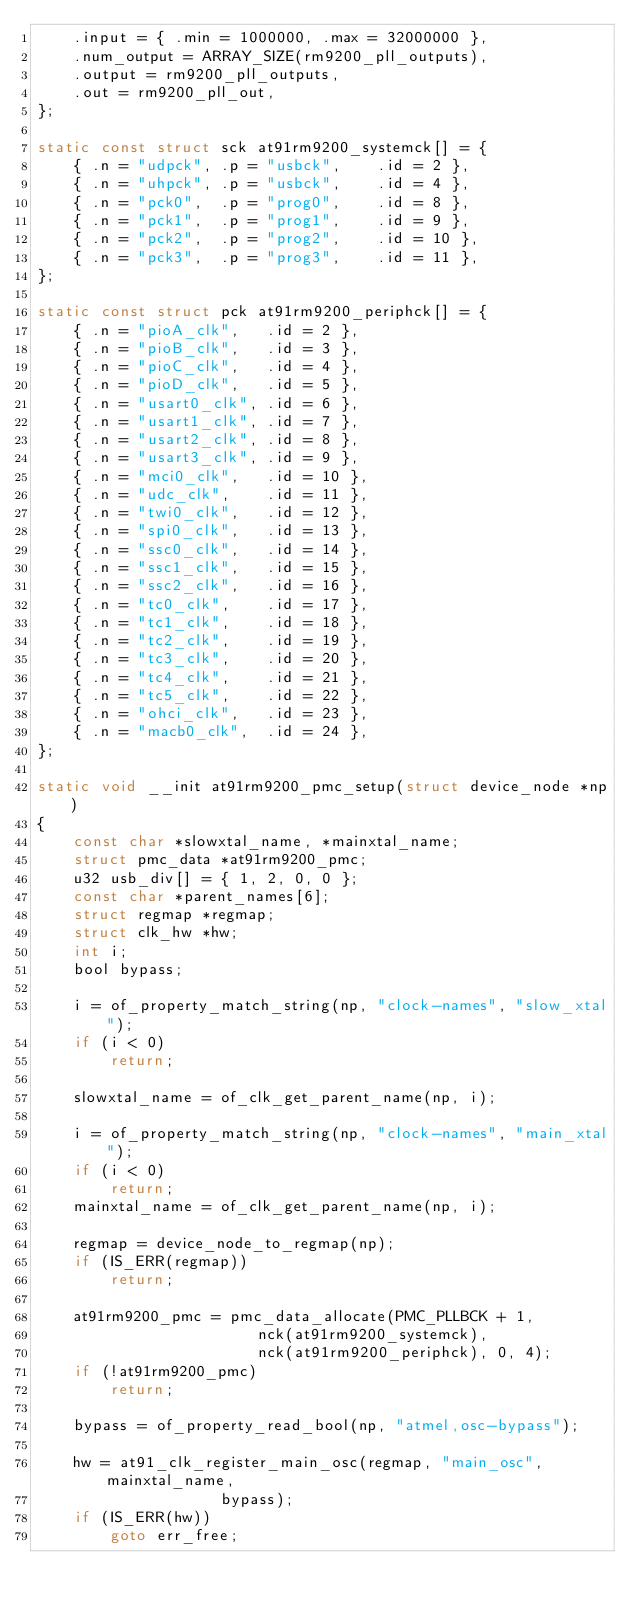Convert code to text. <code><loc_0><loc_0><loc_500><loc_500><_C_>	.input = { .min = 1000000, .max = 32000000 },
	.num_output = ARRAY_SIZE(rm9200_pll_outputs),
	.output = rm9200_pll_outputs,
	.out = rm9200_pll_out,
};

static const struct sck at91rm9200_systemck[] = {
	{ .n = "udpck", .p = "usbck",    .id = 2 },
	{ .n = "uhpck", .p = "usbck",    .id = 4 },
	{ .n = "pck0",  .p = "prog0",    .id = 8 },
	{ .n = "pck1",  .p = "prog1",    .id = 9 },
	{ .n = "pck2",  .p = "prog2",    .id = 10 },
	{ .n = "pck3",  .p = "prog3",    .id = 11 },
};

static const struct pck at91rm9200_periphck[] = {
	{ .n = "pioA_clk",   .id = 2 },
	{ .n = "pioB_clk",   .id = 3 },
	{ .n = "pioC_clk",   .id = 4 },
	{ .n = "pioD_clk",   .id = 5 },
	{ .n = "usart0_clk", .id = 6 },
	{ .n = "usart1_clk", .id = 7 },
	{ .n = "usart2_clk", .id = 8 },
	{ .n = "usart3_clk", .id = 9 },
	{ .n = "mci0_clk",   .id = 10 },
	{ .n = "udc_clk",    .id = 11 },
	{ .n = "twi0_clk",   .id = 12 },
	{ .n = "spi0_clk",   .id = 13 },
	{ .n = "ssc0_clk",   .id = 14 },
	{ .n = "ssc1_clk",   .id = 15 },
	{ .n = "ssc2_clk",   .id = 16 },
	{ .n = "tc0_clk",    .id = 17 },
	{ .n = "tc1_clk",    .id = 18 },
	{ .n = "tc2_clk",    .id = 19 },
	{ .n = "tc3_clk",    .id = 20 },
	{ .n = "tc4_clk",    .id = 21 },
	{ .n = "tc5_clk",    .id = 22 },
	{ .n = "ohci_clk",   .id = 23 },
	{ .n = "macb0_clk",  .id = 24 },
};

static void __init at91rm9200_pmc_setup(struct device_node *np)
{
	const char *slowxtal_name, *mainxtal_name;
	struct pmc_data *at91rm9200_pmc;
	u32 usb_div[] = { 1, 2, 0, 0 };
	const char *parent_names[6];
	struct regmap *regmap;
	struct clk_hw *hw;
	int i;
	bool bypass;

	i = of_property_match_string(np, "clock-names", "slow_xtal");
	if (i < 0)
		return;

	slowxtal_name = of_clk_get_parent_name(np, i);

	i = of_property_match_string(np, "clock-names", "main_xtal");
	if (i < 0)
		return;
	mainxtal_name = of_clk_get_parent_name(np, i);

	regmap = device_node_to_regmap(np);
	if (IS_ERR(regmap))
		return;

	at91rm9200_pmc = pmc_data_allocate(PMC_PLLBCK + 1,
					    nck(at91rm9200_systemck),
					    nck(at91rm9200_periphck), 0, 4);
	if (!at91rm9200_pmc)
		return;

	bypass = of_property_read_bool(np, "atmel,osc-bypass");

	hw = at91_clk_register_main_osc(regmap, "main_osc", mainxtal_name,
					bypass);
	if (IS_ERR(hw))
		goto err_free;
</code> 